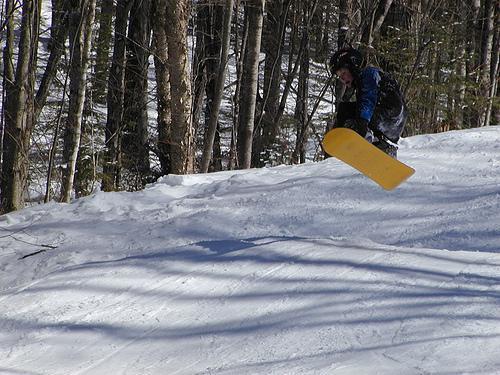How many snowboards can you see?
Give a very brief answer. 1. How many giraffes are looking at the camera?
Give a very brief answer. 0. 